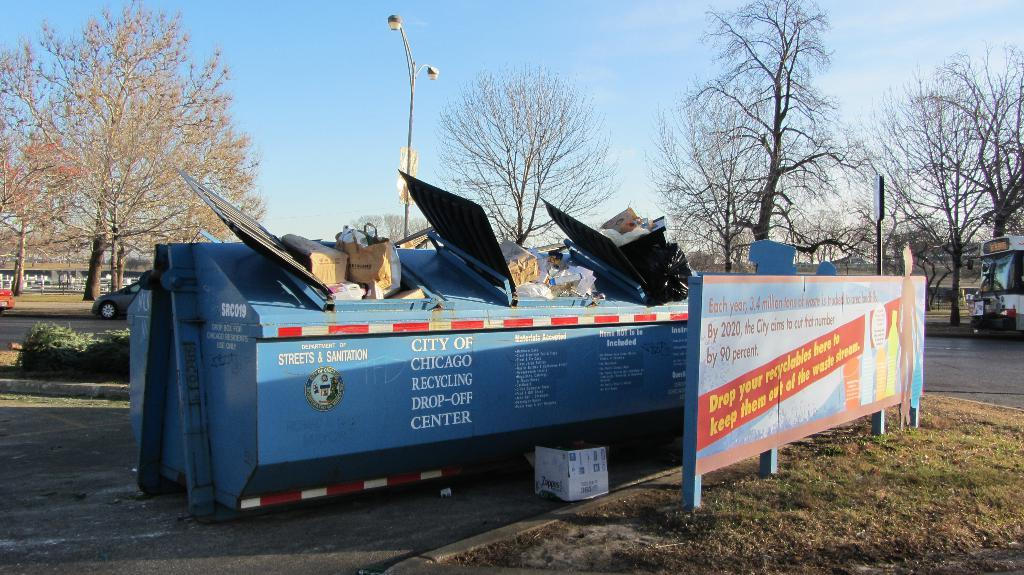<image>
Create a compact narrative representing the image presented. A big blue dumpster from the city of Chicago has a lot of stuff in it. 